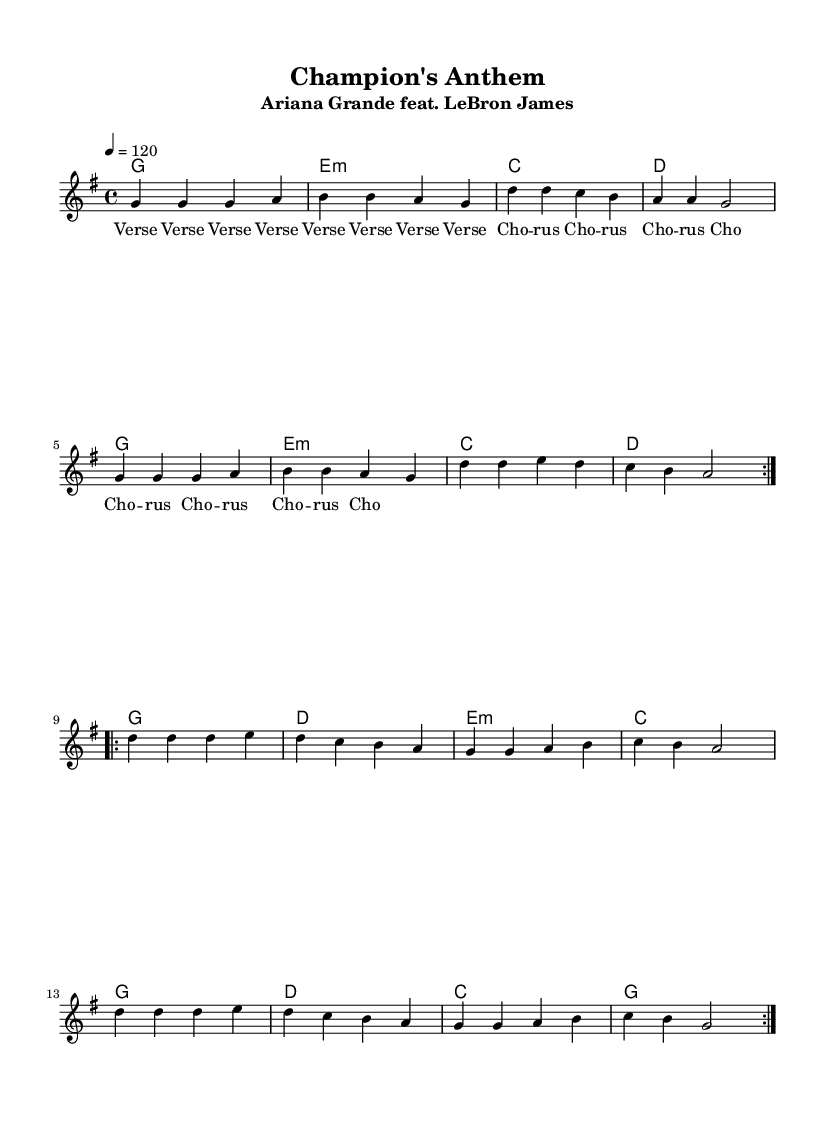What is the title of the piece? The title is prominently displayed at the top of the sheet music, indicating the name of the composition.
Answer: Champion's Anthem What is the key signature of this music? The key signature is identified by looking at the beginning of the music staff. This piece is in G major, which has one sharp (F#).
Answer: G major What is the time signature used in the music? The time signature can be found at the beginning of the score, indicating how many beats are in each measure. This piece has a time signature of 4/4, meaning there are four beats per measure.
Answer: 4/4 What is the tempo marking of the piece? The tempo marking is given in the score and indicates the speed at which the piece should be played. Here, it is set to a quarter note equals 120 beats per minute.
Answer: 120 How many verses are in the structure of the song? By analyzing the lyrics section in the sheet music, it can be observed that the term 'Verse' is repeated four times, indicating the sections devoted to verses.
Answer: 4 What is the main chord progression used in the verses? The chord progression can be deduced from the harmonies section next to the melody. The primary chords for the verses consist of G, E minor, C, and D, repeating in a specified order.
Answer: G, E minor, C, D What is the role of the featured athlete in this collaboration? The presence of LeBron James indicated in the title suggests that he likely has a vocal or performance role in the collaboration, contributing to the theme of the song.
Answer: Vocal/Performance role 